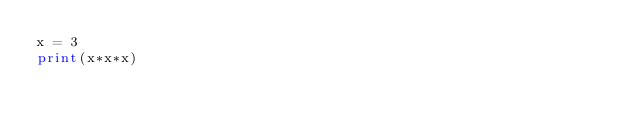Convert code to text. <code><loc_0><loc_0><loc_500><loc_500><_Python_>x = 3
print(x*x*x)
</code> 